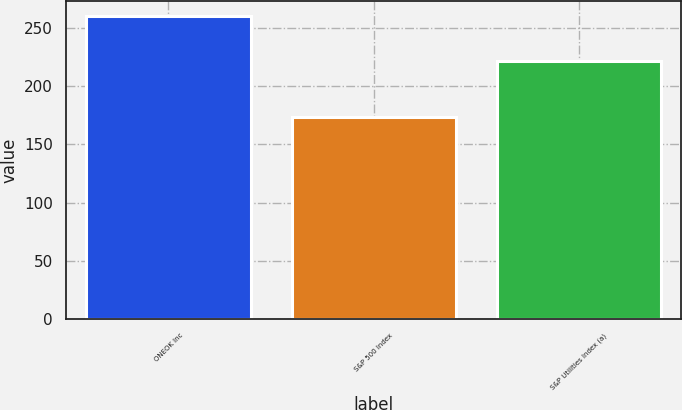<chart> <loc_0><loc_0><loc_500><loc_500><bar_chart><fcel>ONEOK Inc<fcel>S&P 500 Index<fcel>S&P Utilities Index (a)<nl><fcel>259.72<fcel>173.34<fcel>221.82<nl></chart> 